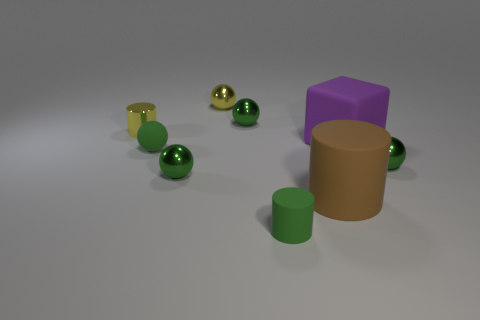Subtract all green spheres. How many were subtracted if there are2green spheres left? 2 Subtract all gray cylinders. How many green spheres are left? 4 Subtract all small metallic balls. How many balls are left? 1 Subtract 1 cylinders. How many cylinders are left? 2 Subtract all yellow balls. How many balls are left? 4 Add 1 small brown cubes. How many objects exist? 10 Subtract all cyan spheres. Subtract all green cylinders. How many spheres are left? 5 Subtract all cylinders. How many objects are left? 6 Add 7 big rubber cylinders. How many big rubber cylinders exist? 8 Subtract 0 gray cubes. How many objects are left? 9 